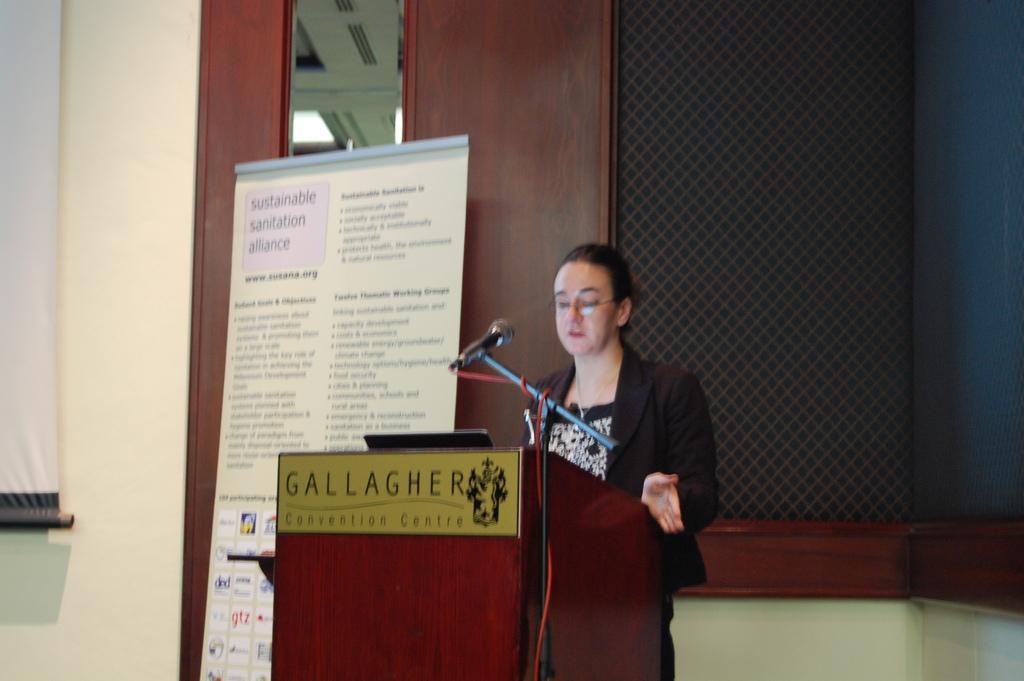Could you give a brief overview of what you see in this image? In this picture there is a woman wearing blazer and black dress. She is standing near to the speech desk. On the desk there is a laptop and mic. Beside her we can see a banner. On the top right we can see black color cloth. On the left there is a projector screen near to the door. 